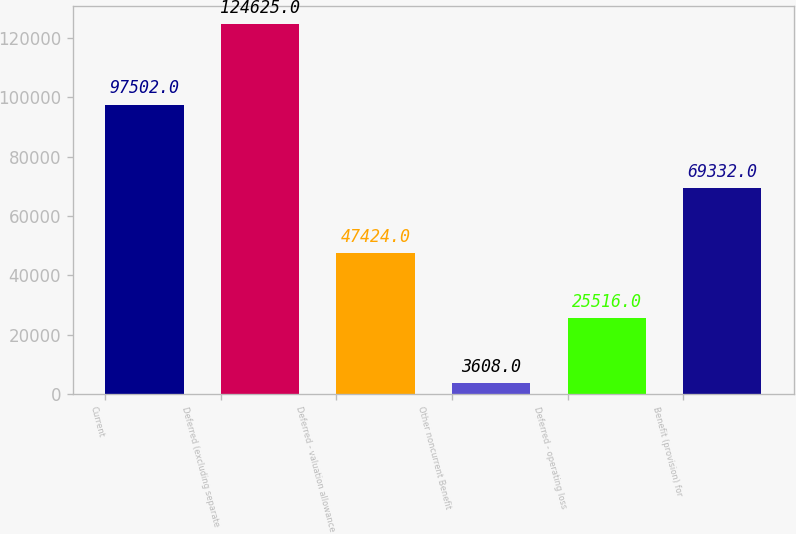Convert chart to OTSL. <chart><loc_0><loc_0><loc_500><loc_500><bar_chart><fcel>Current<fcel>Deferred (excluding separate<fcel>Deferred - valuation allowance<fcel>Other noncurrent Benefit<fcel>Deferred - operating loss<fcel>Benefit (provision) for<nl><fcel>97502<fcel>124625<fcel>47424<fcel>3608<fcel>25516<fcel>69332<nl></chart> 